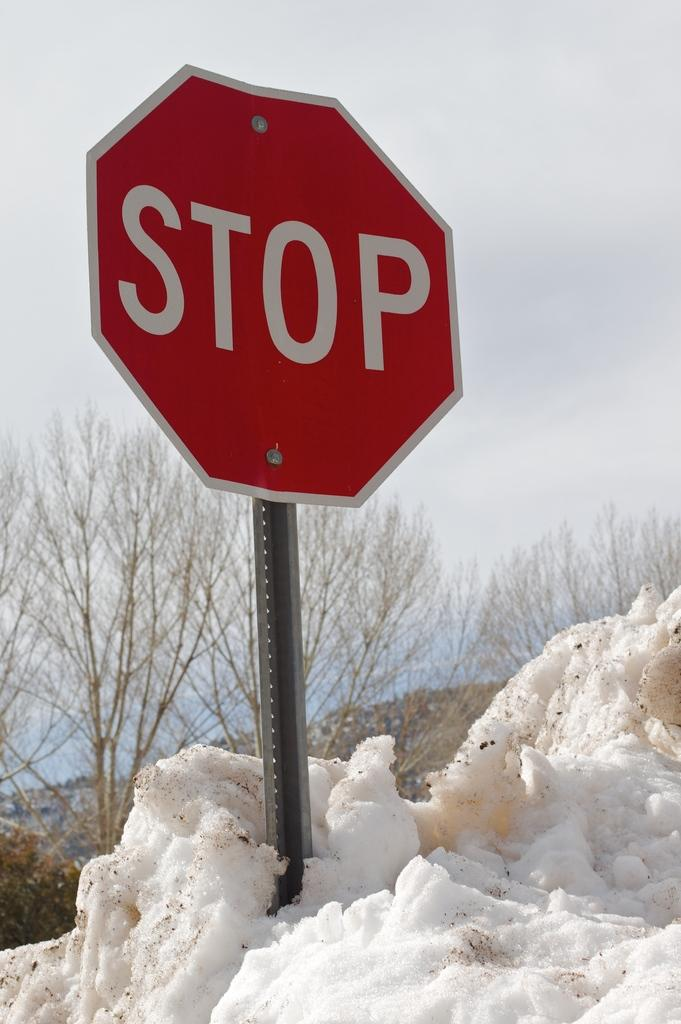<image>
Offer a succinct explanation of the picture presented. a 'stop' sign in a pile of snow outside 